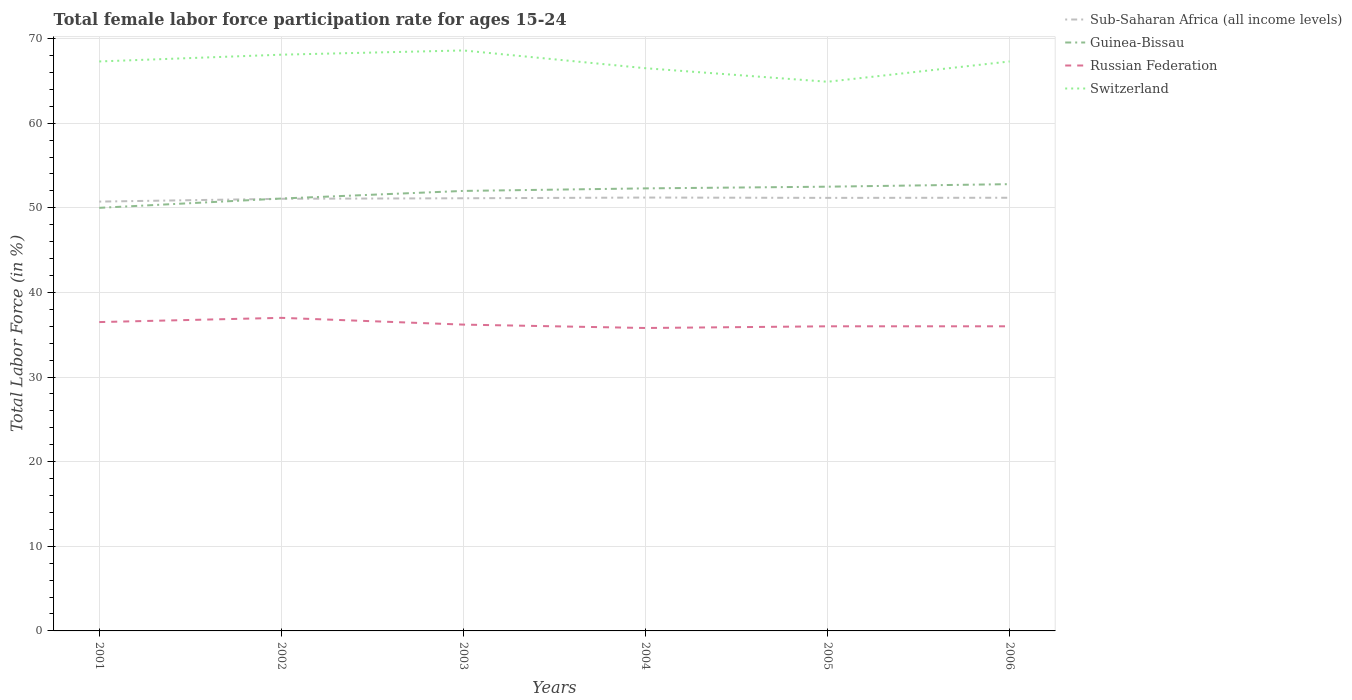Is the number of lines equal to the number of legend labels?
Provide a succinct answer. Yes. Across all years, what is the maximum female labor force participation rate in Sub-Saharan Africa (all income levels)?
Make the answer very short. 50.74. In which year was the female labor force participation rate in Switzerland maximum?
Your answer should be very brief. 2005. What is the total female labor force participation rate in Sub-Saharan Africa (all income levels) in the graph?
Ensure brevity in your answer.  -0.05. What is the difference between the highest and the second highest female labor force participation rate in Russian Federation?
Your response must be concise. 1.2. What is the difference between the highest and the lowest female labor force participation rate in Switzerland?
Provide a succinct answer. 4. How many lines are there?
Make the answer very short. 4. What is the difference between two consecutive major ticks on the Y-axis?
Offer a terse response. 10. Are the values on the major ticks of Y-axis written in scientific E-notation?
Provide a short and direct response. No. Does the graph contain grids?
Your response must be concise. Yes. Where does the legend appear in the graph?
Your answer should be very brief. Top right. How many legend labels are there?
Give a very brief answer. 4. How are the legend labels stacked?
Ensure brevity in your answer.  Vertical. What is the title of the graph?
Provide a short and direct response. Total female labor force participation rate for ages 15-24. What is the label or title of the X-axis?
Give a very brief answer. Years. What is the label or title of the Y-axis?
Provide a short and direct response. Total Labor Force (in %). What is the Total Labor Force (in %) of Sub-Saharan Africa (all income levels) in 2001?
Your response must be concise. 50.74. What is the Total Labor Force (in %) of Russian Federation in 2001?
Provide a succinct answer. 36.5. What is the Total Labor Force (in %) of Switzerland in 2001?
Provide a short and direct response. 67.3. What is the Total Labor Force (in %) in Sub-Saharan Africa (all income levels) in 2002?
Give a very brief answer. 51.07. What is the Total Labor Force (in %) of Guinea-Bissau in 2002?
Keep it short and to the point. 51.1. What is the Total Labor Force (in %) of Russian Federation in 2002?
Your answer should be very brief. 37. What is the Total Labor Force (in %) of Switzerland in 2002?
Provide a short and direct response. 68.1. What is the Total Labor Force (in %) in Sub-Saharan Africa (all income levels) in 2003?
Your response must be concise. 51.13. What is the Total Labor Force (in %) of Guinea-Bissau in 2003?
Keep it short and to the point. 52. What is the Total Labor Force (in %) of Russian Federation in 2003?
Provide a short and direct response. 36.2. What is the Total Labor Force (in %) in Switzerland in 2003?
Your answer should be compact. 68.6. What is the Total Labor Force (in %) in Sub-Saharan Africa (all income levels) in 2004?
Make the answer very short. 51.22. What is the Total Labor Force (in %) in Guinea-Bissau in 2004?
Your answer should be compact. 52.3. What is the Total Labor Force (in %) in Russian Federation in 2004?
Your response must be concise. 35.8. What is the Total Labor Force (in %) of Switzerland in 2004?
Your response must be concise. 66.5. What is the Total Labor Force (in %) in Sub-Saharan Africa (all income levels) in 2005?
Give a very brief answer. 51.18. What is the Total Labor Force (in %) of Guinea-Bissau in 2005?
Ensure brevity in your answer.  52.5. What is the Total Labor Force (in %) of Switzerland in 2005?
Offer a terse response. 64.9. What is the Total Labor Force (in %) in Sub-Saharan Africa (all income levels) in 2006?
Give a very brief answer. 51.19. What is the Total Labor Force (in %) of Guinea-Bissau in 2006?
Give a very brief answer. 52.8. What is the Total Labor Force (in %) of Russian Federation in 2006?
Provide a short and direct response. 36. What is the Total Labor Force (in %) of Switzerland in 2006?
Keep it short and to the point. 67.3. Across all years, what is the maximum Total Labor Force (in %) of Sub-Saharan Africa (all income levels)?
Your response must be concise. 51.22. Across all years, what is the maximum Total Labor Force (in %) of Guinea-Bissau?
Offer a very short reply. 52.8. Across all years, what is the maximum Total Labor Force (in %) in Russian Federation?
Your response must be concise. 37. Across all years, what is the maximum Total Labor Force (in %) in Switzerland?
Give a very brief answer. 68.6. Across all years, what is the minimum Total Labor Force (in %) in Sub-Saharan Africa (all income levels)?
Offer a terse response. 50.74. Across all years, what is the minimum Total Labor Force (in %) in Russian Federation?
Ensure brevity in your answer.  35.8. Across all years, what is the minimum Total Labor Force (in %) in Switzerland?
Give a very brief answer. 64.9. What is the total Total Labor Force (in %) of Sub-Saharan Africa (all income levels) in the graph?
Keep it short and to the point. 306.53. What is the total Total Labor Force (in %) in Guinea-Bissau in the graph?
Provide a short and direct response. 310.7. What is the total Total Labor Force (in %) of Russian Federation in the graph?
Make the answer very short. 217.5. What is the total Total Labor Force (in %) of Switzerland in the graph?
Make the answer very short. 402.7. What is the difference between the Total Labor Force (in %) in Sub-Saharan Africa (all income levels) in 2001 and that in 2002?
Ensure brevity in your answer.  -0.33. What is the difference between the Total Labor Force (in %) in Guinea-Bissau in 2001 and that in 2002?
Provide a succinct answer. -1.1. What is the difference between the Total Labor Force (in %) of Sub-Saharan Africa (all income levels) in 2001 and that in 2003?
Ensure brevity in your answer.  -0.39. What is the difference between the Total Labor Force (in %) in Guinea-Bissau in 2001 and that in 2003?
Give a very brief answer. -2. What is the difference between the Total Labor Force (in %) of Russian Federation in 2001 and that in 2003?
Offer a terse response. 0.3. What is the difference between the Total Labor Force (in %) in Sub-Saharan Africa (all income levels) in 2001 and that in 2004?
Your answer should be compact. -0.48. What is the difference between the Total Labor Force (in %) of Russian Federation in 2001 and that in 2004?
Ensure brevity in your answer.  0.7. What is the difference between the Total Labor Force (in %) in Switzerland in 2001 and that in 2004?
Provide a succinct answer. 0.8. What is the difference between the Total Labor Force (in %) in Sub-Saharan Africa (all income levels) in 2001 and that in 2005?
Ensure brevity in your answer.  -0.44. What is the difference between the Total Labor Force (in %) in Russian Federation in 2001 and that in 2005?
Ensure brevity in your answer.  0.5. What is the difference between the Total Labor Force (in %) in Switzerland in 2001 and that in 2005?
Your answer should be very brief. 2.4. What is the difference between the Total Labor Force (in %) of Sub-Saharan Africa (all income levels) in 2001 and that in 2006?
Your response must be concise. -0.46. What is the difference between the Total Labor Force (in %) in Russian Federation in 2001 and that in 2006?
Your answer should be very brief. 0.5. What is the difference between the Total Labor Force (in %) in Switzerland in 2001 and that in 2006?
Give a very brief answer. 0. What is the difference between the Total Labor Force (in %) of Sub-Saharan Africa (all income levels) in 2002 and that in 2003?
Provide a succinct answer. -0.06. What is the difference between the Total Labor Force (in %) in Switzerland in 2002 and that in 2003?
Keep it short and to the point. -0.5. What is the difference between the Total Labor Force (in %) in Sub-Saharan Africa (all income levels) in 2002 and that in 2004?
Provide a succinct answer. -0.15. What is the difference between the Total Labor Force (in %) of Russian Federation in 2002 and that in 2004?
Make the answer very short. 1.2. What is the difference between the Total Labor Force (in %) in Sub-Saharan Africa (all income levels) in 2002 and that in 2005?
Your response must be concise. -0.11. What is the difference between the Total Labor Force (in %) in Guinea-Bissau in 2002 and that in 2005?
Keep it short and to the point. -1.4. What is the difference between the Total Labor Force (in %) in Switzerland in 2002 and that in 2005?
Give a very brief answer. 3.2. What is the difference between the Total Labor Force (in %) in Sub-Saharan Africa (all income levels) in 2002 and that in 2006?
Your answer should be compact. -0.12. What is the difference between the Total Labor Force (in %) in Switzerland in 2002 and that in 2006?
Offer a terse response. 0.8. What is the difference between the Total Labor Force (in %) of Sub-Saharan Africa (all income levels) in 2003 and that in 2004?
Offer a very short reply. -0.08. What is the difference between the Total Labor Force (in %) of Switzerland in 2003 and that in 2004?
Offer a terse response. 2.1. What is the difference between the Total Labor Force (in %) of Sub-Saharan Africa (all income levels) in 2003 and that in 2005?
Provide a succinct answer. -0.05. What is the difference between the Total Labor Force (in %) in Russian Federation in 2003 and that in 2005?
Your answer should be compact. 0.2. What is the difference between the Total Labor Force (in %) of Switzerland in 2003 and that in 2005?
Your answer should be compact. 3.7. What is the difference between the Total Labor Force (in %) of Sub-Saharan Africa (all income levels) in 2003 and that in 2006?
Your response must be concise. -0.06. What is the difference between the Total Labor Force (in %) in Russian Federation in 2003 and that in 2006?
Provide a succinct answer. 0.2. What is the difference between the Total Labor Force (in %) of Sub-Saharan Africa (all income levels) in 2004 and that in 2005?
Your answer should be very brief. 0.04. What is the difference between the Total Labor Force (in %) of Guinea-Bissau in 2004 and that in 2005?
Offer a terse response. -0.2. What is the difference between the Total Labor Force (in %) in Russian Federation in 2004 and that in 2005?
Provide a short and direct response. -0.2. What is the difference between the Total Labor Force (in %) in Sub-Saharan Africa (all income levels) in 2004 and that in 2006?
Your answer should be very brief. 0.02. What is the difference between the Total Labor Force (in %) of Sub-Saharan Africa (all income levels) in 2005 and that in 2006?
Provide a short and direct response. -0.01. What is the difference between the Total Labor Force (in %) in Russian Federation in 2005 and that in 2006?
Keep it short and to the point. 0. What is the difference between the Total Labor Force (in %) of Sub-Saharan Africa (all income levels) in 2001 and the Total Labor Force (in %) of Guinea-Bissau in 2002?
Give a very brief answer. -0.36. What is the difference between the Total Labor Force (in %) of Sub-Saharan Africa (all income levels) in 2001 and the Total Labor Force (in %) of Russian Federation in 2002?
Ensure brevity in your answer.  13.74. What is the difference between the Total Labor Force (in %) of Sub-Saharan Africa (all income levels) in 2001 and the Total Labor Force (in %) of Switzerland in 2002?
Give a very brief answer. -17.36. What is the difference between the Total Labor Force (in %) of Guinea-Bissau in 2001 and the Total Labor Force (in %) of Switzerland in 2002?
Ensure brevity in your answer.  -18.1. What is the difference between the Total Labor Force (in %) in Russian Federation in 2001 and the Total Labor Force (in %) in Switzerland in 2002?
Offer a terse response. -31.6. What is the difference between the Total Labor Force (in %) in Sub-Saharan Africa (all income levels) in 2001 and the Total Labor Force (in %) in Guinea-Bissau in 2003?
Offer a very short reply. -1.26. What is the difference between the Total Labor Force (in %) in Sub-Saharan Africa (all income levels) in 2001 and the Total Labor Force (in %) in Russian Federation in 2003?
Keep it short and to the point. 14.54. What is the difference between the Total Labor Force (in %) in Sub-Saharan Africa (all income levels) in 2001 and the Total Labor Force (in %) in Switzerland in 2003?
Make the answer very short. -17.86. What is the difference between the Total Labor Force (in %) in Guinea-Bissau in 2001 and the Total Labor Force (in %) in Russian Federation in 2003?
Provide a short and direct response. 13.8. What is the difference between the Total Labor Force (in %) in Guinea-Bissau in 2001 and the Total Labor Force (in %) in Switzerland in 2003?
Provide a succinct answer. -18.6. What is the difference between the Total Labor Force (in %) of Russian Federation in 2001 and the Total Labor Force (in %) of Switzerland in 2003?
Your answer should be very brief. -32.1. What is the difference between the Total Labor Force (in %) of Sub-Saharan Africa (all income levels) in 2001 and the Total Labor Force (in %) of Guinea-Bissau in 2004?
Your response must be concise. -1.56. What is the difference between the Total Labor Force (in %) in Sub-Saharan Africa (all income levels) in 2001 and the Total Labor Force (in %) in Russian Federation in 2004?
Offer a very short reply. 14.94. What is the difference between the Total Labor Force (in %) in Sub-Saharan Africa (all income levels) in 2001 and the Total Labor Force (in %) in Switzerland in 2004?
Provide a short and direct response. -15.76. What is the difference between the Total Labor Force (in %) in Guinea-Bissau in 2001 and the Total Labor Force (in %) in Switzerland in 2004?
Give a very brief answer. -16.5. What is the difference between the Total Labor Force (in %) in Sub-Saharan Africa (all income levels) in 2001 and the Total Labor Force (in %) in Guinea-Bissau in 2005?
Make the answer very short. -1.76. What is the difference between the Total Labor Force (in %) of Sub-Saharan Africa (all income levels) in 2001 and the Total Labor Force (in %) of Russian Federation in 2005?
Your answer should be very brief. 14.74. What is the difference between the Total Labor Force (in %) of Sub-Saharan Africa (all income levels) in 2001 and the Total Labor Force (in %) of Switzerland in 2005?
Keep it short and to the point. -14.16. What is the difference between the Total Labor Force (in %) of Guinea-Bissau in 2001 and the Total Labor Force (in %) of Russian Federation in 2005?
Offer a terse response. 14. What is the difference between the Total Labor Force (in %) of Guinea-Bissau in 2001 and the Total Labor Force (in %) of Switzerland in 2005?
Offer a very short reply. -14.9. What is the difference between the Total Labor Force (in %) of Russian Federation in 2001 and the Total Labor Force (in %) of Switzerland in 2005?
Your answer should be compact. -28.4. What is the difference between the Total Labor Force (in %) in Sub-Saharan Africa (all income levels) in 2001 and the Total Labor Force (in %) in Guinea-Bissau in 2006?
Offer a terse response. -2.06. What is the difference between the Total Labor Force (in %) in Sub-Saharan Africa (all income levels) in 2001 and the Total Labor Force (in %) in Russian Federation in 2006?
Provide a succinct answer. 14.74. What is the difference between the Total Labor Force (in %) in Sub-Saharan Africa (all income levels) in 2001 and the Total Labor Force (in %) in Switzerland in 2006?
Keep it short and to the point. -16.56. What is the difference between the Total Labor Force (in %) of Guinea-Bissau in 2001 and the Total Labor Force (in %) of Switzerland in 2006?
Provide a succinct answer. -17.3. What is the difference between the Total Labor Force (in %) of Russian Federation in 2001 and the Total Labor Force (in %) of Switzerland in 2006?
Your answer should be compact. -30.8. What is the difference between the Total Labor Force (in %) of Sub-Saharan Africa (all income levels) in 2002 and the Total Labor Force (in %) of Guinea-Bissau in 2003?
Your answer should be very brief. -0.93. What is the difference between the Total Labor Force (in %) of Sub-Saharan Africa (all income levels) in 2002 and the Total Labor Force (in %) of Russian Federation in 2003?
Provide a short and direct response. 14.87. What is the difference between the Total Labor Force (in %) in Sub-Saharan Africa (all income levels) in 2002 and the Total Labor Force (in %) in Switzerland in 2003?
Offer a terse response. -17.53. What is the difference between the Total Labor Force (in %) of Guinea-Bissau in 2002 and the Total Labor Force (in %) of Russian Federation in 2003?
Make the answer very short. 14.9. What is the difference between the Total Labor Force (in %) in Guinea-Bissau in 2002 and the Total Labor Force (in %) in Switzerland in 2003?
Make the answer very short. -17.5. What is the difference between the Total Labor Force (in %) in Russian Federation in 2002 and the Total Labor Force (in %) in Switzerland in 2003?
Your response must be concise. -31.6. What is the difference between the Total Labor Force (in %) of Sub-Saharan Africa (all income levels) in 2002 and the Total Labor Force (in %) of Guinea-Bissau in 2004?
Your answer should be compact. -1.23. What is the difference between the Total Labor Force (in %) of Sub-Saharan Africa (all income levels) in 2002 and the Total Labor Force (in %) of Russian Federation in 2004?
Your answer should be very brief. 15.27. What is the difference between the Total Labor Force (in %) in Sub-Saharan Africa (all income levels) in 2002 and the Total Labor Force (in %) in Switzerland in 2004?
Your answer should be very brief. -15.43. What is the difference between the Total Labor Force (in %) in Guinea-Bissau in 2002 and the Total Labor Force (in %) in Russian Federation in 2004?
Your response must be concise. 15.3. What is the difference between the Total Labor Force (in %) in Guinea-Bissau in 2002 and the Total Labor Force (in %) in Switzerland in 2004?
Keep it short and to the point. -15.4. What is the difference between the Total Labor Force (in %) in Russian Federation in 2002 and the Total Labor Force (in %) in Switzerland in 2004?
Provide a succinct answer. -29.5. What is the difference between the Total Labor Force (in %) of Sub-Saharan Africa (all income levels) in 2002 and the Total Labor Force (in %) of Guinea-Bissau in 2005?
Offer a very short reply. -1.43. What is the difference between the Total Labor Force (in %) in Sub-Saharan Africa (all income levels) in 2002 and the Total Labor Force (in %) in Russian Federation in 2005?
Provide a succinct answer. 15.07. What is the difference between the Total Labor Force (in %) in Sub-Saharan Africa (all income levels) in 2002 and the Total Labor Force (in %) in Switzerland in 2005?
Give a very brief answer. -13.83. What is the difference between the Total Labor Force (in %) of Guinea-Bissau in 2002 and the Total Labor Force (in %) of Russian Federation in 2005?
Your answer should be very brief. 15.1. What is the difference between the Total Labor Force (in %) in Russian Federation in 2002 and the Total Labor Force (in %) in Switzerland in 2005?
Make the answer very short. -27.9. What is the difference between the Total Labor Force (in %) in Sub-Saharan Africa (all income levels) in 2002 and the Total Labor Force (in %) in Guinea-Bissau in 2006?
Ensure brevity in your answer.  -1.73. What is the difference between the Total Labor Force (in %) of Sub-Saharan Africa (all income levels) in 2002 and the Total Labor Force (in %) of Russian Federation in 2006?
Your answer should be very brief. 15.07. What is the difference between the Total Labor Force (in %) in Sub-Saharan Africa (all income levels) in 2002 and the Total Labor Force (in %) in Switzerland in 2006?
Offer a very short reply. -16.23. What is the difference between the Total Labor Force (in %) of Guinea-Bissau in 2002 and the Total Labor Force (in %) of Switzerland in 2006?
Your answer should be compact. -16.2. What is the difference between the Total Labor Force (in %) in Russian Federation in 2002 and the Total Labor Force (in %) in Switzerland in 2006?
Make the answer very short. -30.3. What is the difference between the Total Labor Force (in %) of Sub-Saharan Africa (all income levels) in 2003 and the Total Labor Force (in %) of Guinea-Bissau in 2004?
Ensure brevity in your answer.  -1.17. What is the difference between the Total Labor Force (in %) in Sub-Saharan Africa (all income levels) in 2003 and the Total Labor Force (in %) in Russian Federation in 2004?
Give a very brief answer. 15.33. What is the difference between the Total Labor Force (in %) in Sub-Saharan Africa (all income levels) in 2003 and the Total Labor Force (in %) in Switzerland in 2004?
Provide a short and direct response. -15.37. What is the difference between the Total Labor Force (in %) of Guinea-Bissau in 2003 and the Total Labor Force (in %) of Russian Federation in 2004?
Offer a terse response. 16.2. What is the difference between the Total Labor Force (in %) in Guinea-Bissau in 2003 and the Total Labor Force (in %) in Switzerland in 2004?
Provide a short and direct response. -14.5. What is the difference between the Total Labor Force (in %) in Russian Federation in 2003 and the Total Labor Force (in %) in Switzerland in 2004?
Offer a terse response. -30.3. What is the difference between the Total Labor Force (in %) in Sub-Saharan Africa (all income levels) in 2003 and the Total Labor Force (in %) in Guinea-Bissau in 2005?
Make the answer very short. -1.37. What is the difference between the Total Labor Force (in %) of Sub-Saharan Africa (all income levels) in 2003 and the Total Labor Force (in %) of Russian Federation in 2005?
Your answer should be compact. 15.13. What is the difference between the Total Labor Force (in %) in Sub-Saharan Africa (all income levels) in 2003 and the Total Labor Force (in %) in Switzerland in 2005?
Provide a short and direct response. -13.77. What is the difference between the Total Labor Force (in %) of Guinea-Bissau in 2003 and the Total Labor Force (in %) of Switzerland in 2005?
Offer a very short reply. -12.9. What is the difference between the Total Labor Force (in %) in Russian Federation in 2003 and the Total Labor Force (in %) in Switzerland in 2005?
Your response must be concise. -28.7. What is the difference between the Total Labor Force (in %) of Sub-Saharan Africa (all income levels) in 2003 and the Total Labor Force (in %) of Guinea-Bissau in 2006?
Offer a terse response. -1.67. What is the difference between the Total Labor Force (in %) of Sub-Saharan Africa (all income levels) in 2003 and the Total Labor Force (in %) of Russian Federation in 2006?
Your answer should be compact. 15.13. What is the difference between the Total Labor Force (in %) in Sub-Saharan Africa (all income levels) in 2003 and the Total Labor Force (in %) in Switzerland in 2006?
Provide a short and direct response. -16.17. What is the difference between the Total Labor Force (in %) in Guinea-Bissau in 2003 and the Total Labor Force (in %) in Switzerland in 2006?
Your answer should be very brief. -15.3. What is the difference between the Total Labor Force (in %) of Russian Federation in 2003 and the Total Labor Force (in %) of Switzerland in 2006?
Provide a short and direct response. -31.1. What is the difference between the Total Labor Force (in %) of Sub-Saharan Africa (all income levels) in 2004 and the Total Labor Force (in %) of Guinea-Bissau in 2005?
Provide a succinct answer. -1.28. What is the difference between the Total Labor Force (in %) in Sub-Saharan Africa (all income levels) in 2004 and the Total Labor Force (in %) in Russian Federation in 2005?
Offer a terse response. 15.22. What is the difference between the Total Labor Force (in %) in Sub-Saharan Africa (all income levels) in 2004 and the Total Labor Force (in %) in Switzerland in 2005?
Keep it short and to the point. -13.68. What is the difference between the Total Labor Force (in %) in Guinea-Bissau in 2004 and the Total Labor Force (in %) in Switzerland in 2005?
Your answer should be compact. -12.6. What is the difference between the Total Labor Force (in %) in Russian Federation in 2004 and the Total Labor Force (in %) in Switzerland in 2005?
Give a very brief answer. -29.1. What is the difference between the Total Labor Force (in %) of Sub-Saharan Africa (all income levels) in 2004 and the Total Labor Force (in %) of Guinea-Bissau in 2006?
Offer a terse response. -1.58. What is the difference between the Total Labor Force (in %) in Sub-Saharan Africa (all income levels) in 2004 and the Total Labor Force (in %) in Russian Federation in 2006?
Your answer should be very brief. 15.22. What is the difference between the Total Labor Force (in %) in Sub-Saharan Africa (all income levels) in 2004 and the Total Labor Force (in %) in Switzerland in 2006?
Give a very brief answer. -16.08. What is the difference between the Total Labor Force (in %) of Guinea-Bissau in 2004 and the Total Labor Force (in %) of Russian Federation in 2006?
Provide a succinct answer. 16.3. What is the difference between the Total Labor Force (in %) of Russian Federation in 2004 and the Total Labor Force (in %) of Switzerland in 2006?
Your answer should be very brief. -31.5. What is the difference between the Total Labor Force (in %) of Sub-Saharan Africa (all income levels) in 2005 and the Total Labor Force (in %) of Guinea-Bissau in 2006?
Your answer should be compact. -1.62. What is the difference between the Total Labor Force (in %) of Sub-Saharan Africa (all income levels) in 2005 and the Total Labor Force (in %) of Russian Federation in 2006?
Ensure brevity in your answer.  15.18. What is the difference between the Total Labor Force (in %) of Sub-Saharan Africa (all income levels) in 2005 and the Total Labor Force (in %) of Switzerland in 2006?
Provide a short and direct response. -16.12. What is the difference between the Total Labor Force (in %) in Guinea-Bissau in 2005 and the Total Labor Force (in %) in Switzerland in 2006?
Make the answer very short. -14.8. What is the difference between the Total Labor Force (in %) of Russian Federation in 2005 and the Total Labor Force (in %) of Switzerland in 2006?
Ensure brevity in your answer.  -31.3. What is the average Total Labor Force (in %) in Sub-Saharan Africa (all income levels) per year?
Make the answer very short. 51.09. What is the average Total Labor Force (in %) of Guinea-Bissau per year?
Offer a terse response. 51.78. What is the average Total Labor Force (in %) in Russian Federation per year?
Your answer should be compact. 36.25. What is the average Total Labor Force (in %) in Switzerland per year?
Ensure brevity in your answer.  67.12. In the year 2001, what is the difference between the Total Labor Force (in %) in Sub-Saharan Africa (all income levels) and Total Labor Force (in %) in Guinea-Bissau?
Provide a succinct answer. 0.74. In the year 2001, what is the difference between the Total Labor Force (in %) in Sub-Saharan Africa (all income levels) and Total Labor Force (in %) in Russian Federation?
Your answer should be very brief. 14.24. In the year 2001, what is the difference between the Total Labor Force (in %) in Sub-Saharan Africa (all income levels) and Total Labor Force (in %) in Switzerland?
Offer a very short reply. -16.56. In the year 2001, what is the difference between the Total Labor Force (in %) in Guinea-Bissau and Total Labor Force (in %) in Switzerland?
Give a very brief answer. -17.3. In the year 2001, what is the difference between the Total Labor Force (in %) of Russian Federation and Total Labor Force (in %) of Switzerland?
Make the answer very short. -30.8. In the year 2002, what is the difference between the Total Labor Force (in %) in Sub-Saharan Africa (all income levels) and Total Labor Force (in %) in Guinea-Bissau?
Offer a very short reply. -0.03. In the year 2002, what is the difference between the Total Labor Force (in %) of Sub-Saharan Africa (all income levels) and Total Labor Force (in %) of Russian Federation?
Provide a short and direct response. 14.07. In the year 2002, what is the difference between the Total Labor Force (in %) of Sub-Saharan Africa (all income levels) and Total Labor Force (in %) of Switzerland?
Offer a terse response. -17.03. In the year 2002, what is the difference between the Total Labor Force (in %) of Russian Federation and Total Labor Force (in %) of Switzerland?
Make the answer very short. -31.1. In the year 2003, what is the difference between the Total Labor Force (in %) of Sub-Saharan Africa (all income levels) and Total Labor Force (in %) of Guinea-Bissau?
Your response must be concise. -0.87. In the year 2003, what is the difference between the Total Labor Force (in %) in Sub-Saharan Africa (all income levels) and Total Labor Force (in %) in Russian Federation?
Give a very brief answer. 14.93. In the year 2003, what is the difference between the Total Labor Force (in %) in Sub-Saharan Africa (all income levels) and Total Labor Force (in %) in Switzerland?
Offer a terse response. -17.47. In the year 2003, what is the difference between the Total Labor Force (in %) in Guinea-Bissau and Total Labor Force (in %) in Russian Federation?
Offer a terse response. 15.8. In the year 2003, what is the difference between the Total Labor Force (in %) in Guinea-Bissau and Total Labor Force (in %) in Switzerland?
Your response must be concise. -16.6. In the year 2003, what is the difference between the Total Labor Force (in %) in Russian Federation and Total Labor Force (in %) in Switzerland?
Provide a short and direct response. -32.4. In the year 2004, what is the difference between the Total Labor Force (in %) in Sub-Saharan Africa (all income levels) and Total Labor Force (in %) in Guinea-Bissau?
Make the answer very short. -1.08. In the year 2004, what is the difference between the Total Labor Force (in %) of Sub-Saharan Africa (all income levels) and Total Labor Force (in %) of Russian Federation?
Offer a very short reply. 15.42. In the year 2004, what is the difference between the Total Labor Force (in %) of Sub-Saharan Africa (all income levels) and Total Labor Force (in %) of Switzerland?
Ensure brevity in your answer.  -15.28. In the year 2004, what is the difference between the Total Labor Force (in %) in Guinea-Bissau and Total Labor Force (in %) in Russian Federation?
Offer a terse response. 16.5. In the year 2004, what is the difference between the Total Labor Force (in %) in Guinea-Bissau and Total Labor Force (in %) in Switzerland?
Keep it short and to the point. -14.2. In the year 2004, what is the difference between the Total Labor Force (in %) in Russian Federation and Total Labor Force (in %) in Switzerland?
Keep it short and to the point. -30.7. In the year 2005, what is the difference between the Total Labor Force (in %) in Sub-Saharan Africa (all income levels) and Total Labor Force (in %) in Guinea-Bissau?
Your answer should be compact. -1.32. In the year 2005, what is the difference between the Total Labor Force (in %) in Sub-Saharan Africa (all income levels) and Total Labor Force (in %) in Russian Federation?
Make the answer very short. 15.18. In the year 2005, what is the difference between the Total Labor Force (in %) in Sub-Saharan Africa (all income levels) and Total Labor Force (in %) in Switzerland?
Keep it short and to the point. -13.72. In the year 2005, what is the difference between the Total Labor Force (in %) in Guinea-Bissau and Total Labor Force (in %) in Switzerland?
Your answer should be compact. -12.4. In the year 2005, what is the difference between the Total Labor Force (in %) of Russian Federation and Total Labor Force (in %) of Switzerland?
Your answer should be very brief. -28.9. In the year 2006, what is the difference between the Total Labor Force (in %) of Sub-Saharan Africa (all income levels) and Total Labor Force (in %) of Guinea-Bissau?
Give a very brief answer. -1.61. In the year 2006, what is the difference between the Total Labor Force (in %) of Sub-Saharan Africa (all income levels) and Total Labor Force (in %) of Russian Federation?
Your response must be concise. 15.19. In the year 2006, what is the difference between the Total Labor Force (in %) of Sub-Saharan Africa (all income levels) and Total Labor Force (in %) of Switzerland?
Ensure brevity in your answer.  -16.11. In the year 2006, what is the difference between the Total Labor Force (in %) of Guinea-Bissau and Total Labor Force (in %) of Russian Federation?
Ensure brevity in your answer.  16.8. In the year 2006, what is the difference between the Total Labor Force (in %) of Russian Federation and Total Labor Force (in %) of Switzerland?
Offer a terse response. -31.3. What is the ratio of the Total Labor Force (in %) of Guinea-Bissau in 2001 to that in 2002?
Offer a very short reply. 0.98. What is the ratio of the Total Labor Force (in %) in Russian Federation in 2001 to that in 2002?
Provide a succinct answer. 0.99. What is the ratio of the Total Labor Force (in %) in Switzerland in 2001 to that in 2002?
Make the answer very short. 0.99. What is the ratio of the Total Labor Force (in %) of Sub-Saharan Africa (all income levels) in 2001 to that in 2003?
Your answer should be very brief. 0.99. What is the ratio of the Total Labor Force (in %) of Guinea-Bissau in 2001 to that in 2003?
Provide a succinct answer. 0.96. What is the ratio of the Total Labor Force (in %) of Russian Federation in 2001 to that in 2003?
Make the answer very short. 1.01. What is the ratio of the Total Labor Force (in %) of Sub-Saharan Africa (all income levels) in 2001 to that in 2004?
Provide a succinct answer. 0.99. What is the ratio of the Total Labor Force (in %) of Guinea-Bissau in 2001 to that in 2004?
Offer a very short reply. 0.96. What is the ratio of the Total Labor Force (in %) in Russian Federation in 2001 to that in 2004?
Your answer should be compact. 1.02. What is the ratio of the Total Labor Force (in %) of Switzerland in 2001 to that in 2004?
Ensure brevity in your answer.  1.01. What is the ratio of the Total Labor Force (in %) in Guinea-Bissau in 2001 to that in 2005?
Give a very brief answer. 0.95. What is the ratio of the Total Labor Force (in %) of Russian Federation in 2001 to that in 2005?
Provide a succinct answer. 1.01. What is the ratio of the Total Labor Force (in %) of Sub-Saharan Africa (all income levels) in 2001 to that in 2006?
Ensure brevity in your answer.  0.99. What is the ratio of the Total Labor Force (in %) of Guinea-Bissau in 2001 to that in 2006?
Offer a very short reply. 0.95. What is the ratio of the Total Labor Force (in %) in Russian Federation in 2001 to that in 2006?
Provide a succinct answer. 1.01. What is the ratio of the Total Labor Force (in %) of Switzerland in 2001 to that in 2006?
Your response must be concise. 1. What is the ratio of the Total Labor Force (in %) in Guinea-Bissau in 2002 to that in 2003?
Your answer should be compact. 0.98. What is the ratio of the Total Labor Force (in %) of Russian Federation in 2002 to that in 2003?
Offer a terse response. 1.02. What is the ratio of the Total Labor Force (in %) in Switzerland in 2002 to that in 2003?
Your answer should be compact. 0.99. What is the ratio of the Total Labor Force (in %) of Sub-Saharan Africa (all income levels) in 2002 to that in 2004?
Your answer should be very brief. 1. What is the ratio of the Total Labor Force (in %) in Guinea-Bissau in 2002 to that in 2004?
Offer a very short reply. 0.98. What is the ratio of the Total Labor Force (in %) of Russian Federation in 2002 to that in 2004?
Your answer should be compact. 1.03. What is the ratio of the Total Labor Force (in %) of Switzerland in 2002 to that in 2004?
Ensure brevity in your answer.  1.02. What is the ratio of the Total Labor Force (in %) in Sub-Saharan Africa (all income levels) in 2002 to that in 2005?
Keep it short and to the point. 1. What is the ratio of the Total Labor Force (in %) in Guinea-Bissau in 2002 to that in 2005?
Offer a very short reply. 0.97. What is the ratio of the Total Labor Force (in %) in Russian Federation in 2002 to that in 2005?
Make the answer very short. 1.03. What is the ratio of the Total Labor Force (in %) in Switzerland in 2002 to that in 2005?
Ensure brevity in your answer.  1.05. What is the ratio of the Total Labor Force (in %) of Sub-Saharan Africa (all income levels) in 2002 to that in 2006?
Make the answer very short. 1. What is the ratio of the Total Labor Force (in %) of Guinea-Bissau in 2002 to that in 2006?
Offer a terse response. 0.97. What is the ratio of the Total Labor Force (in %) in Russian Federation in 2002 to that in 2006?
Keep it short and to the point. 1.03. What is the ratio of the Total Labor Force (in %) in Switzerland in 2002 to that in 2006?
Your answer should be very brief. 1.01. What is the ratio of the Total Labor Force (in %) in Russian Federation in 2003 to that in 2004?
Provide a short and direct response. 1.01. What is the ratio of the Total Labor Force (in %) of Switzerland in 2003 to that in 2004?
Provide a succinct answer. 1.03. What is the ratio of the Total Labor Force (in %) of Sub-Saharan Africa (all income levels) in 2003 to that in 2005?
Keep it short and to the point. 1. What is the ratio of the Total Labor Force (in %) in Guinea-Bissau in 2003 to that in 2005?
Make the answer very short. 0.99. What is the ratio of the Total Labor Force (in %) in Russian Federation in 2003 to that in 2005?
Your answer should be compact. 1.01. What is the ratio of the Total Labor Force (in %) of Switzerland in 2003 to that in 2005?
Make the answer very short. 1.06. What is the ratio of the Total Labor Force (in %) in Russian Federation in 2003 to that in 2006?
Offer a terse response. 1.01. What is the ratio of the Total Labor Force (in %) in Switzerland in 2003 to that in 2006?
Your response must be concise. 1.02. What is the ratio of the Total Labor Force (in %) in Guinea-Bissau in 2004 to that in 2005?
Your response must be concise. 1. What is the ratio of the Total Labor Force (in %) in Switzerland in 2004 to that in 2005?
Keep it short and to the point. 1.02. What is the ratio of the Total Labor Force (in %) in Guinea-Bissau in 2004 to that in 2006?
Your answer should be very brief. 0.99. What is the ratio of the Total Labor Force (in %) of Sub-Saharan Africa (all income levels) in 2005 to that in 2006?
Your answer should be compact. 1. What is the ratio of the Total Labor Force (in %) in Switzerland in 2005 to that in 2006?
Your answer should be very brief. 0.96. What is the difference between the highest and the second highest Total Labor Force (in %) of Sub-Saharan Africa (all income levels)?
Offer a very short reply. 0.02. What is the difference between the highest and the second highest Total Labor Force (in %) of Switzerland?
Provide a short and direct response. 0.5. What is the difference between the highest and the lowest Total Labor Force (in %) in Sub-Saharan Africa (all income levels)?
Offer a very short reply. 0.48. What is the difference between the highest and the lowest Total Labor Force (in %) in Russian Federation?
Your response must be concise. 1.2. What is the difference between the highest and the lowest Total Labor Force (in %) of Switzerland?
Provide a succinct answer. 3.7. 